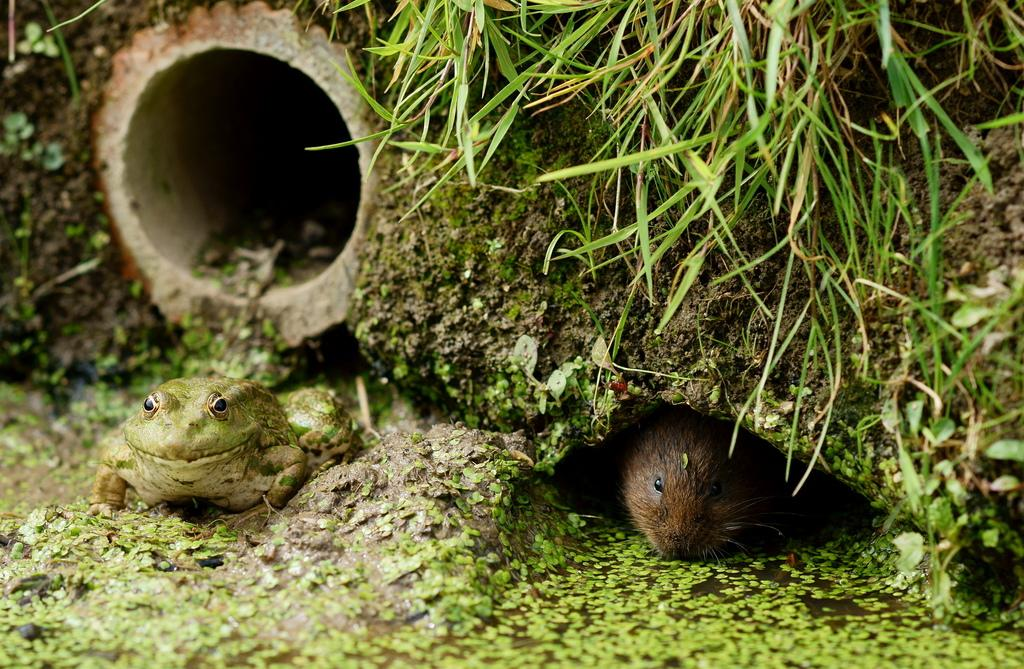What animals can be seen in the image? There is a frog and a rat in the image. Where are the frog and rat located? Both the frog and rat are on the ground. What else can be found on the ground in the image? There is a pipe and grass present on the ground. What does the uncle say about the dirt in the stomach of the frog in the image? There is no uncle or mention of dirt or stomach in the image; it only features a frog, a rat, a pipe, and grass on the ground. 